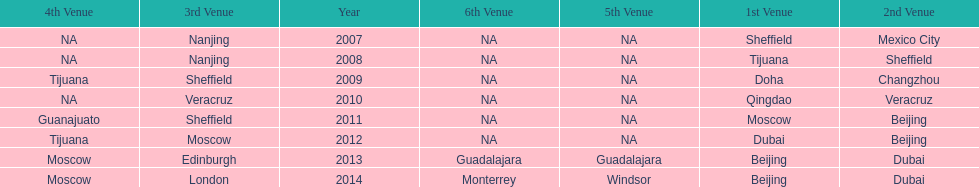In list of venues, how many years was beijing above moscow (1st venue is above 2nd venue, etc)? 3. Help me parse the entirety of this table. {'header': ['4th Venue', '3rd Venue', 'Year', '6th Venue', '5th Venue', '1st Venue', '2nd Venue'], 'rows': [['NA', 'Nanjing', '2007', 'NA', 'NA', 'Sheffield', 'Mexico City'], ['NA', 'Nanjing', '2008', 'NA', 'NA', 'Tijuana', 'Sheffield'], ['Tijuana', 'Sheffield', '2009', 'NA', 'NA', 'Doha', 'Changzhou'], ['NA', 'Veracruz', '2010', 'NA', 'NA', 'Qingdao', 'Veracruz'], ['Guanajuato', 'Sheffield', '2011', 'NA', 'NA', 'Moscow', 'Beijing'], ['Tijuana', 'Moscow', '2012', 'NA', 'NA', 'Dubai', 'Beijing'], ['Moscow', 'Edinburgh', '2013', 'Guadalajara', 'Guadalajara', 'Beijing', 'Dubai'], ['Moscow', 'London', '2014', 'Monterrey', 'Windsor', 'Beijing', 'Dubai']]} 